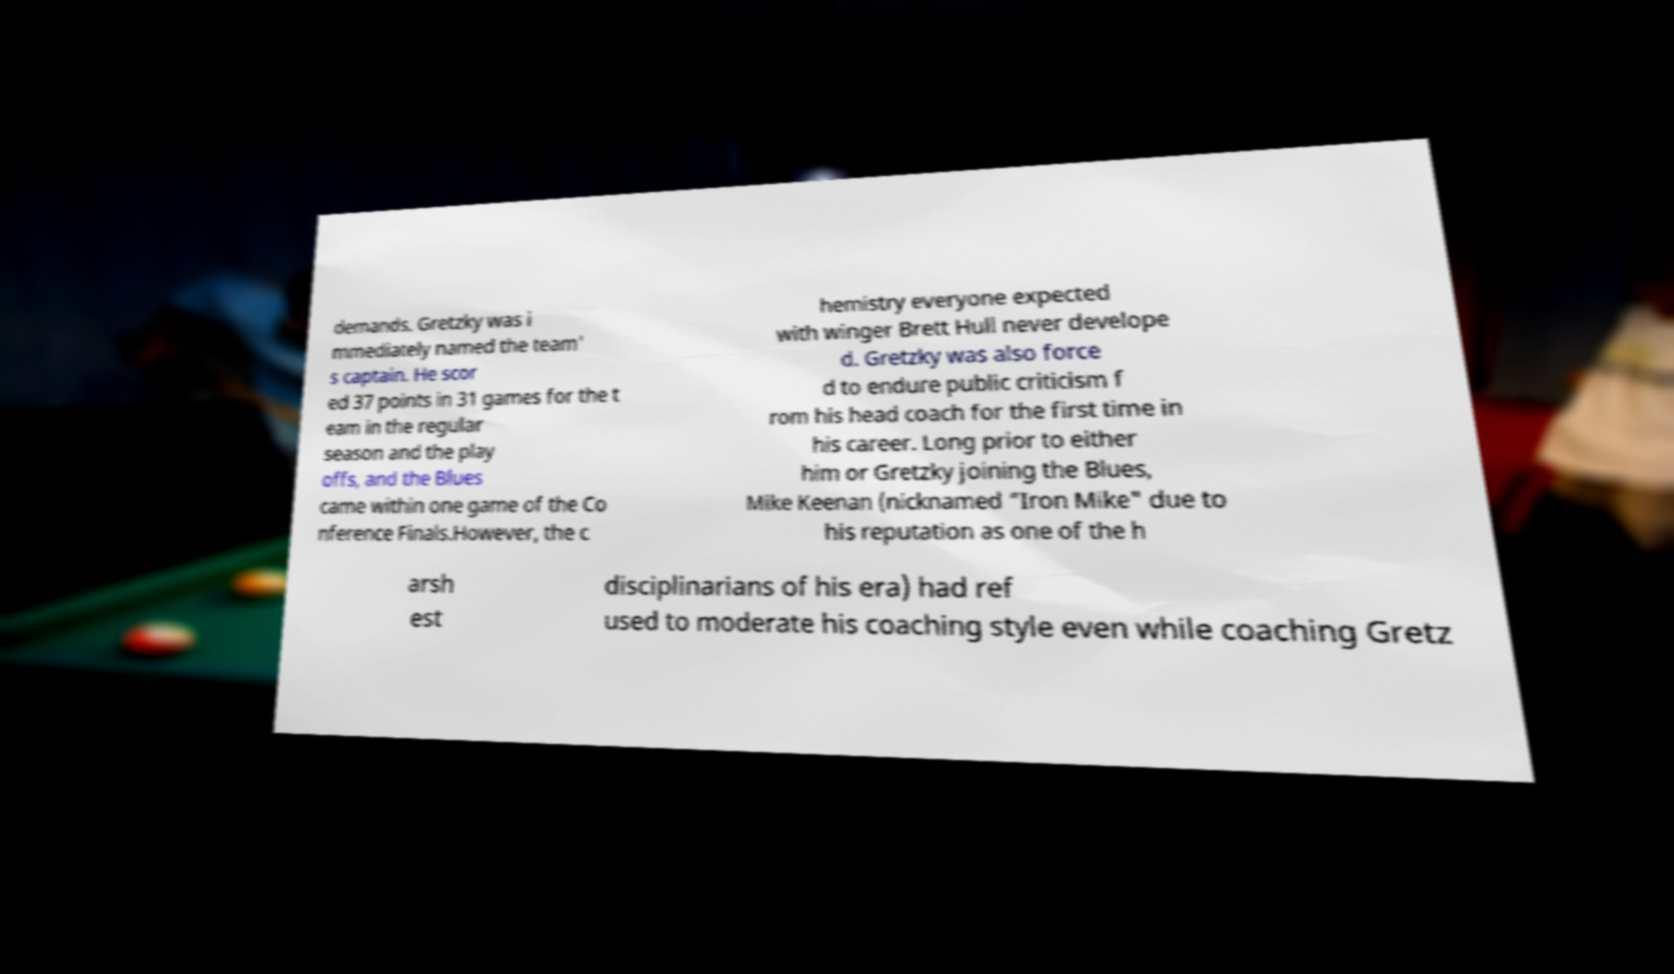Can you accurately transcribe the text from the provided image for me? demands. Gretzky was i mmediately named the team' s captain. He scor ed 37 points in 31 games for the t eam in the regular season and the play offs, and the Blues came within one game of the Co nference Finals.However, the c hemistry everyone expected with winger Brett Hull never develope d. Gretzky was also force d to endure public criticism f rom his head coach for the first time in his career. Long prior to either him or Gretzky joining the Blues, Mike Keenan (nicknamed "Iron Mike" due to his reputation as one of the h arsh est disciplinarians of his era) had ref used to moderate his coaching style even while coaching Gretz 